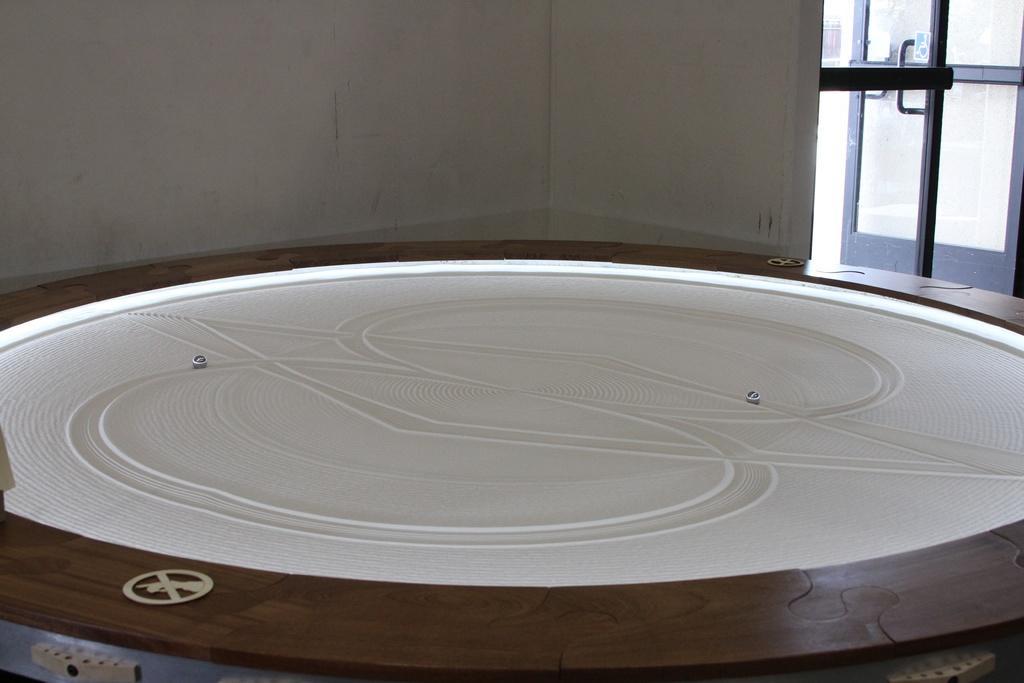Please provide a concise description of this image. Here in this picture we can see a round board present over a place and at the top of it we can see a design present and we can also see a couple of playing marbles present and on the right side we can see glass door present. 